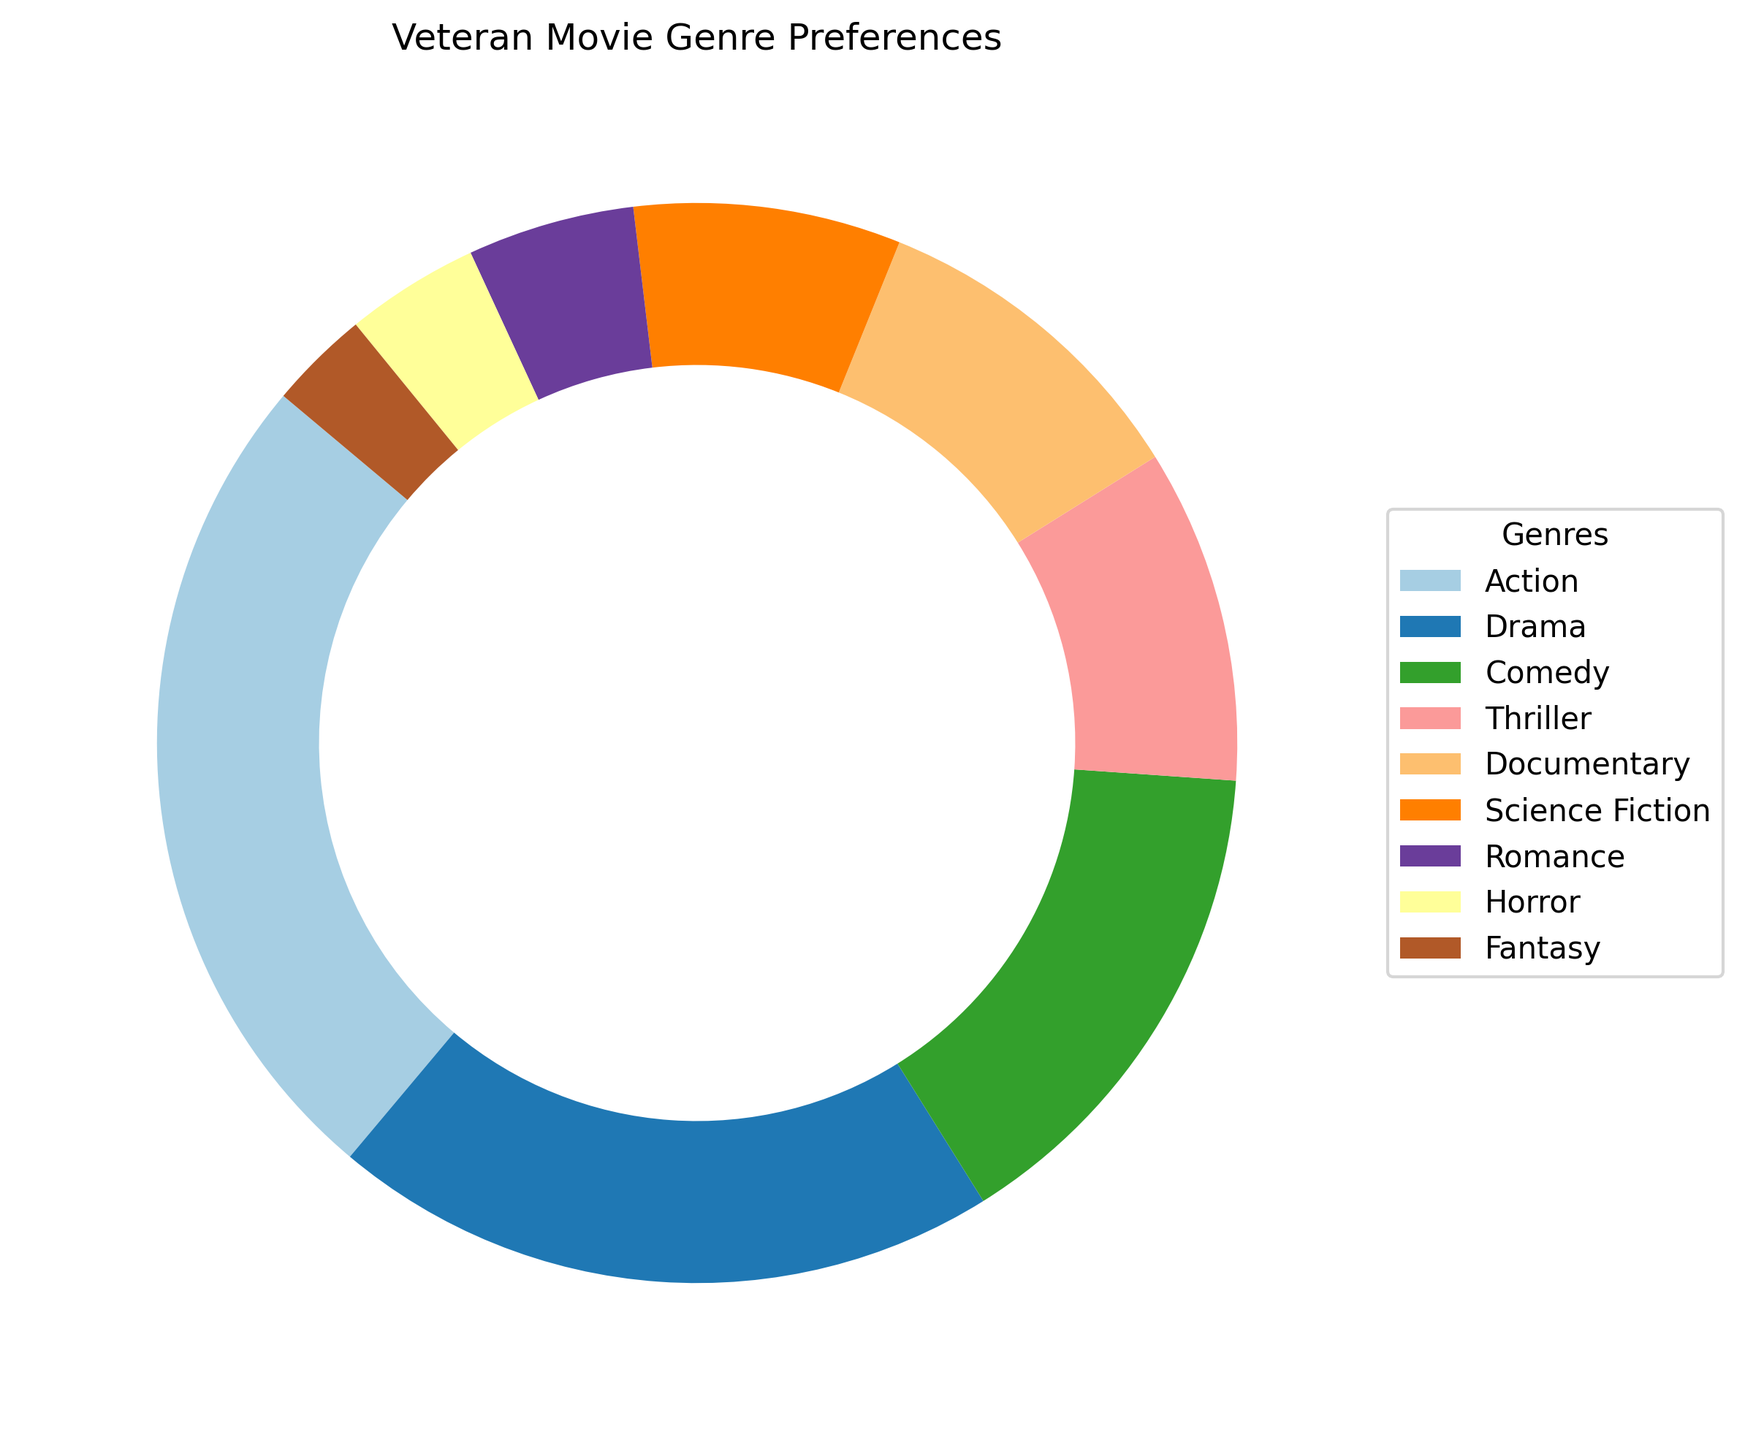Which genre has the highest percentage of preference among veterans? The segment of the ring chart with the largest area corresponds to the action genre which has the highest percentage.
Answer: Action How does the preference for comedy compare to the preference for action? The action genre has 25% while the comedy genre has 15%, meaning the action preference is 10% higher than the comedy preference.
Answer: 10% higher What percentage of veterans prefer either thriller or documentary films? Add the percentages of thriller and documentary: 10% (Thriller) + 10% (Documentary) = 20%.
Answer: 20% Which genres have a smaller preference percentage than comedy? From the chart, the genres with smaller preference percentages compared to comedy's 15% are Thriller (10%), Documentary (10%), Science Fiction (8%), Romance (5%), Horror (4%), and Fantasy (3%).
Answer: Thriller, Documentary, Science Fiction, Romance, Horror, Fantasy What is the total percentage of veterans who prefer either romance, horror, or fantasy movies? Add the percentages of romance, horror, and fantasy: 5% (Romance) + 4% (Horror) + 3% (Fantasy) = 12%.
Answer: 12% Compare the combined preference for action and drama genres to the combined preference for comedy and documentary genres. Add the percentages for each pair and then compare: Action (25%) + Drama (20%) = 45%, Comedy (15%) + Documentary (10%) = 25%. Action and Drama combined preference (45%) is 20% more than Comedy and Documentary combined preference (25%).
Answer: 20% more What is the median preference percentage for the genres shown? Arrange percentages in ascending order and find the middle value: 3%, 4%, 5%, 8%, 10%, 10%, 15%, 20%, 25%. The median value is the fifth one, which is 10%.
Answer: 10% What proportion of veterans prefer science fiction movies? The segment representing science fiction constitutes 8% of the total preferences.
Answer: 8% Is there a genre that has an equal preference percentage to documentary films? According to the chart, thriller films also have a 10% preference, same as documentaries.
Answer: Thriller 